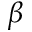Convert formula to latex. <formula><loc_0><loc_0><loc_500><loc_500>\beta</formula> 